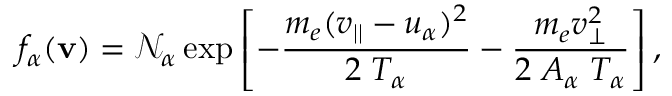Convert formula to latex. <formula><loc_0><loc_0><loc_500><loc_500>f _ { \alpha } ( { v } ) = \mathcal { N } _ { \alpha } \exp \left [ - \frac { m _ { e } ( v _ { | | } - u _ { \alpha } ) ^ { 2 } } { 2 \, T _ { \alpha } } - \frac { m _ { e } v _ { \perp } ^ { 2 } } { 2 \, A _ { \alpha } \, T _ { \alpha } } \right ] ,</formula> 